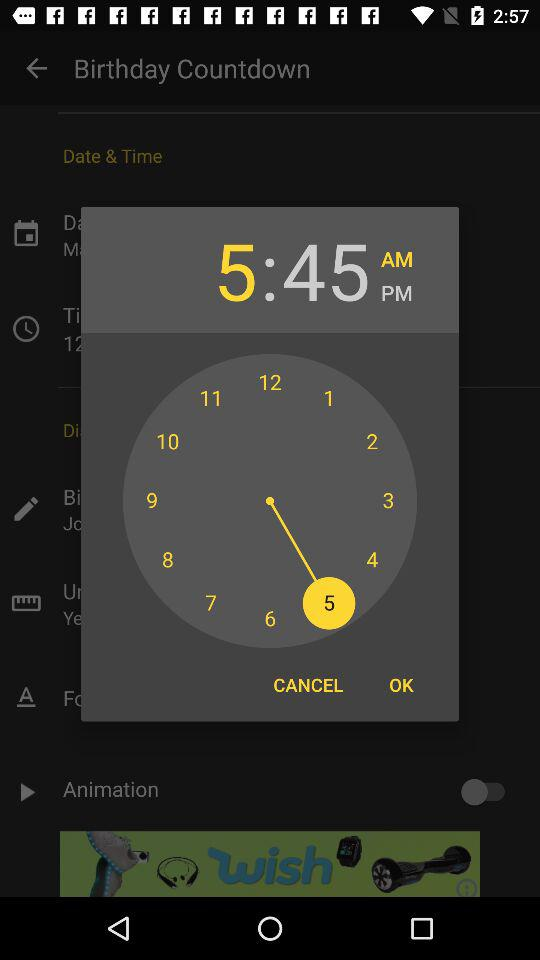What time is shown? The shown time is 5:45 AM. 